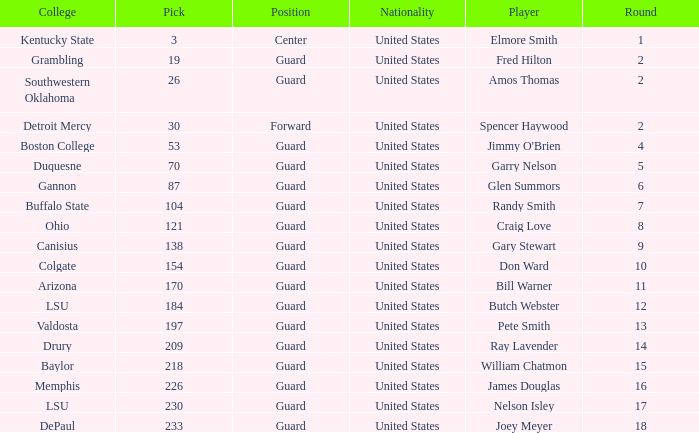WHAT IS THE NATIONALITY FOR SOUTHWESTERN OKLAHOMA? United States. 